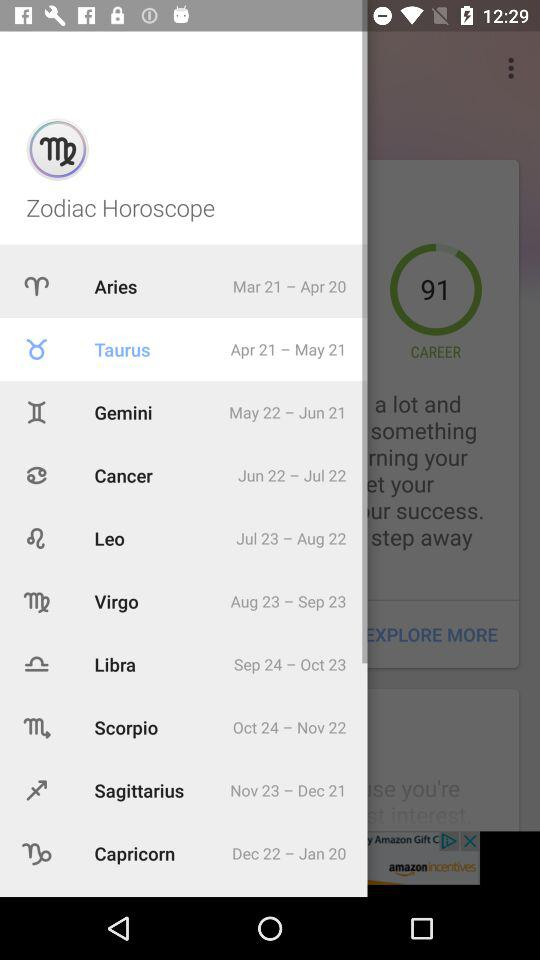What is the time period of Aries? The time period of Aries is from March 21 to April 20. 